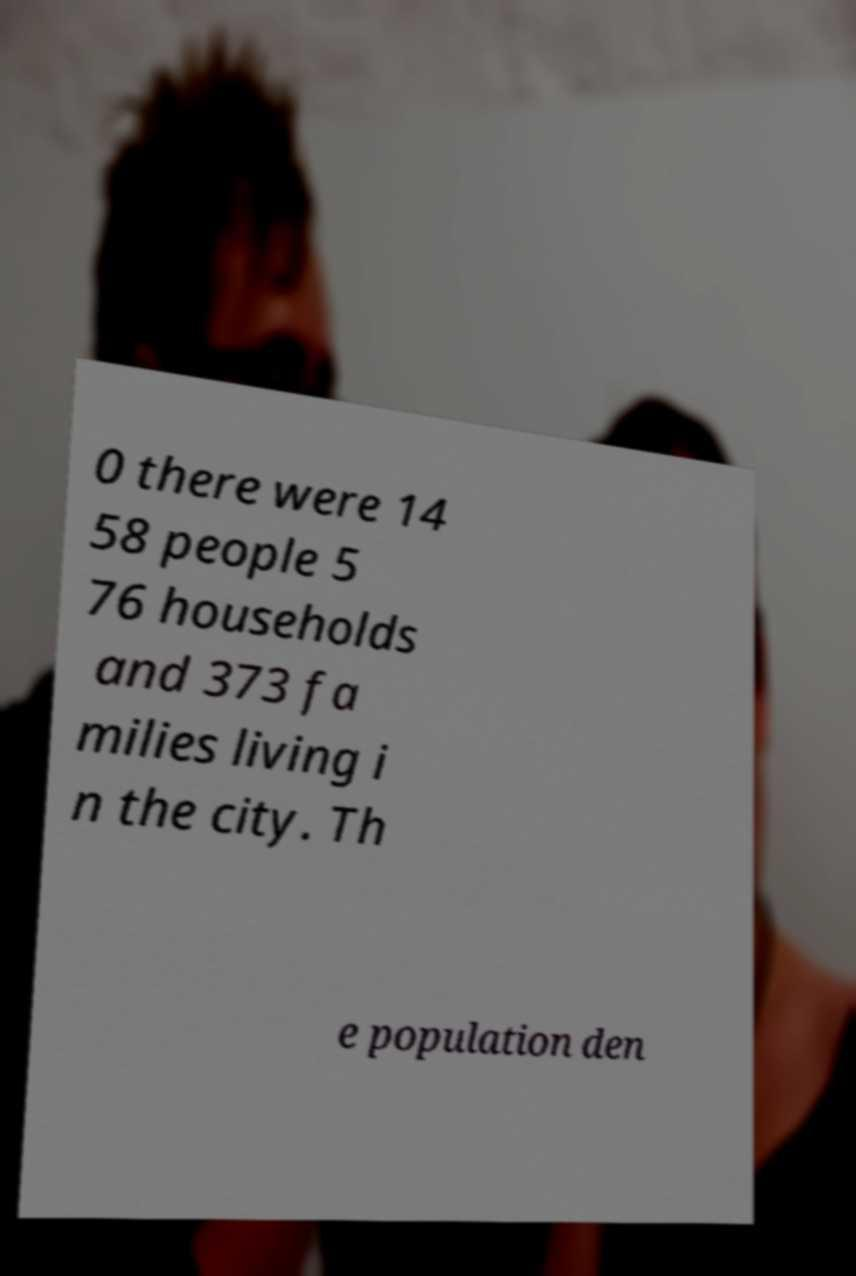What messages or text are displayed in this image? I need them in a readable, typed format. 0 there were 14 58 people 5 76 households and 373 fa milies living i n the city. Th e population den 